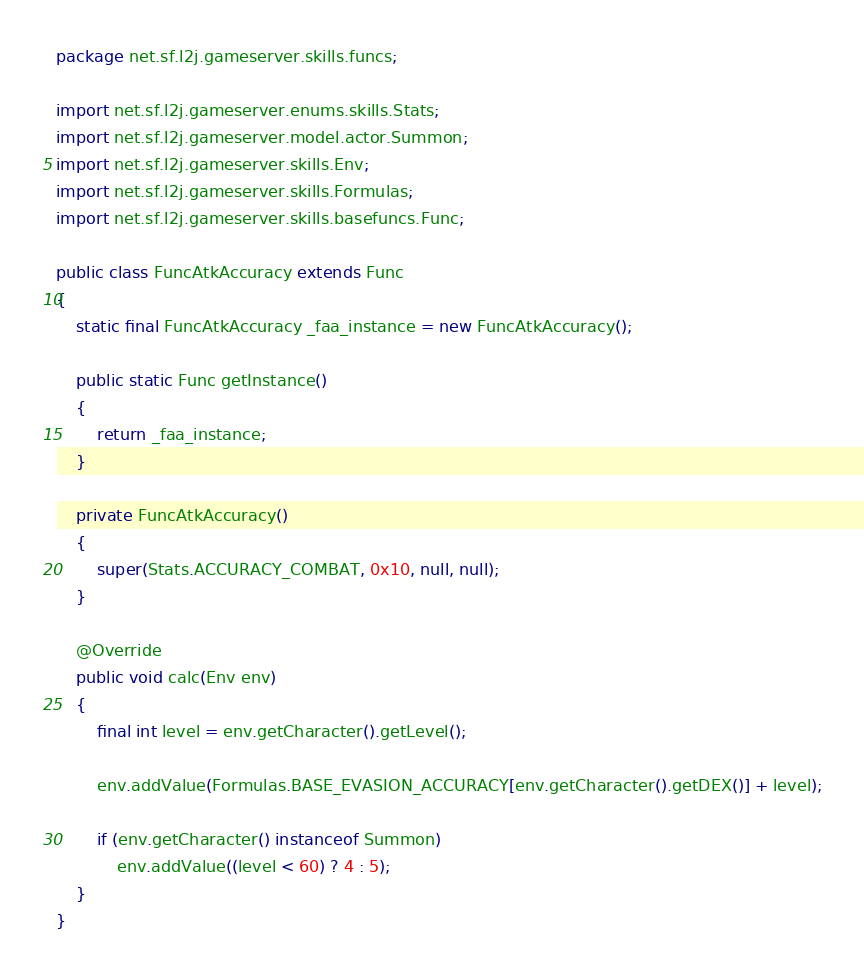Convert code to text. <code><loc_0><loc_0><loc_500><loc_500><_Java_>package net.sf.l2j.gameserver.skills.funcs;

import net.sf.l2j.gameserver.enums.skills.Stats;
import net.sf.l2j.gameserver.model.actor.Summon;
import net.sf.l2j.gameserver.skills.Env;
import net.sf.l2j.gameserver.skills.Formulas;
import net.sf.l2j.gameserver.skills.basefuncs.Func;

public class FuncAtkAccuracy extends Func
{
	static final FuncAtkAccuracy _faa_instance = new FuncAtkAccuracy();
	
	public static Func getInstance()
	{
		return _faa_instance;
	}
	
	private FuncAtkAccuracy()
	{
		super(Stats.ACCURACY_COMBAT, 0x10, null, null);
	}
	
	@Override
	public void calc(Env env)
	{
		final int level = env.getCharacter().getLevel();
		
		env.addValue(Formulas.BASE_EVASION_ACCURACY[env.getCharacter().getDEX()] + level);
		
		if (env.getCharacter() instanceof Summon)
			env.addValue((level < 60) ? 4 : 5);
	}
}</code> 